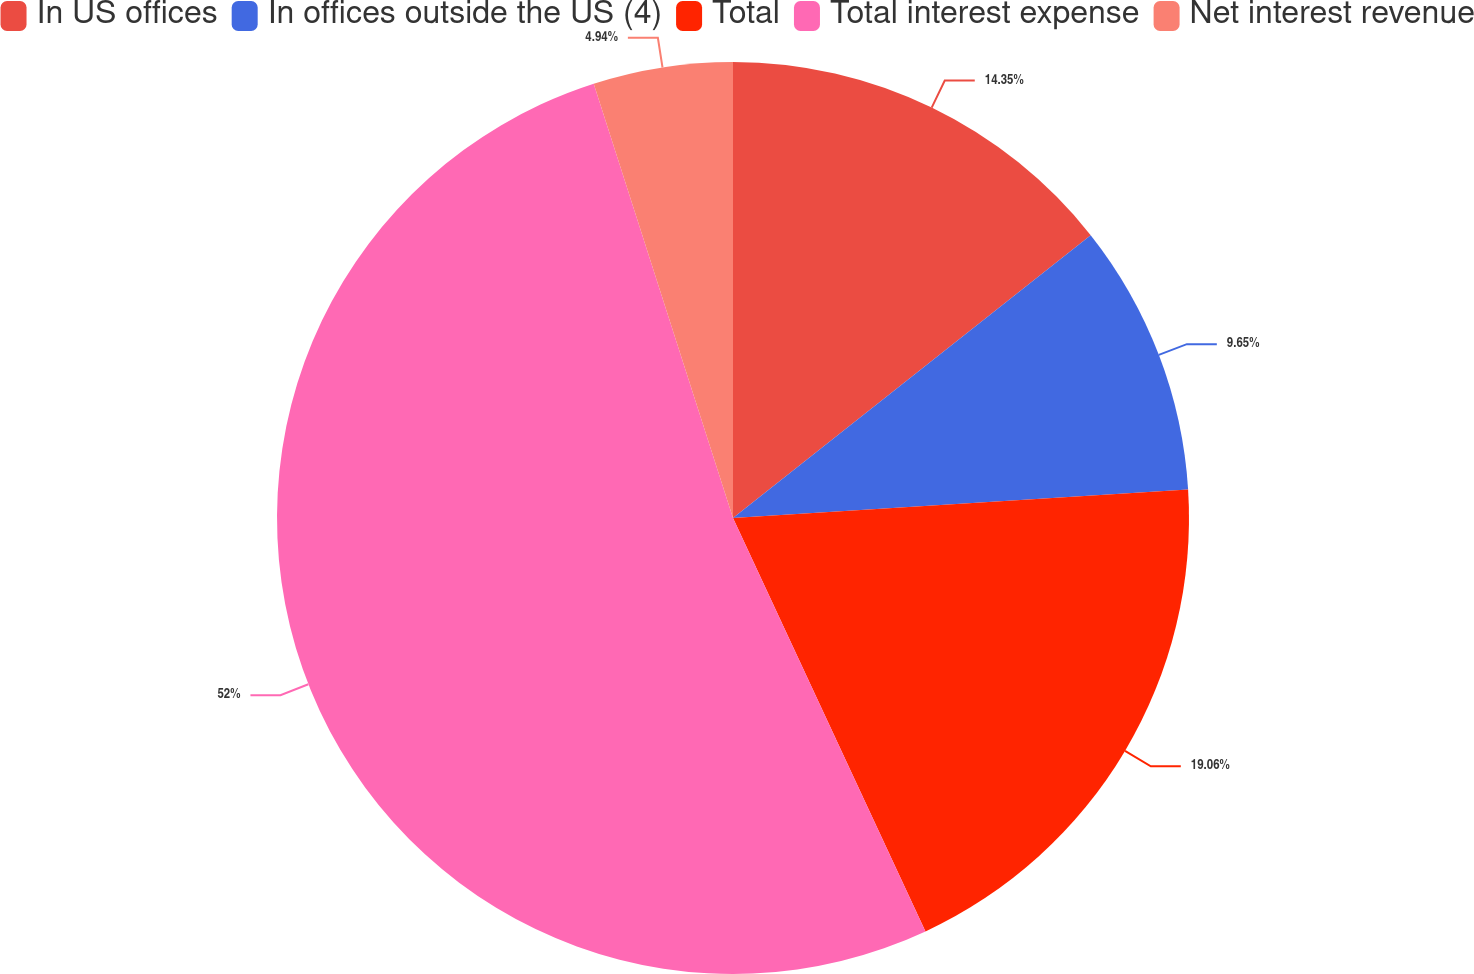Convert chart to OTSL. <chart><loc_0><loc_0><loc_500><loc_500><pie_chart><fcel>In US offices<fcel>In offices outside the US (4)<fcel>Total<fcel>Total interest expense<fcel>Net interest revenue<nl><fcel>14.35%<fcel>9.65%<fcel>19.06%<fcel>51.99%<fcel>4.94%<nl></chart> 